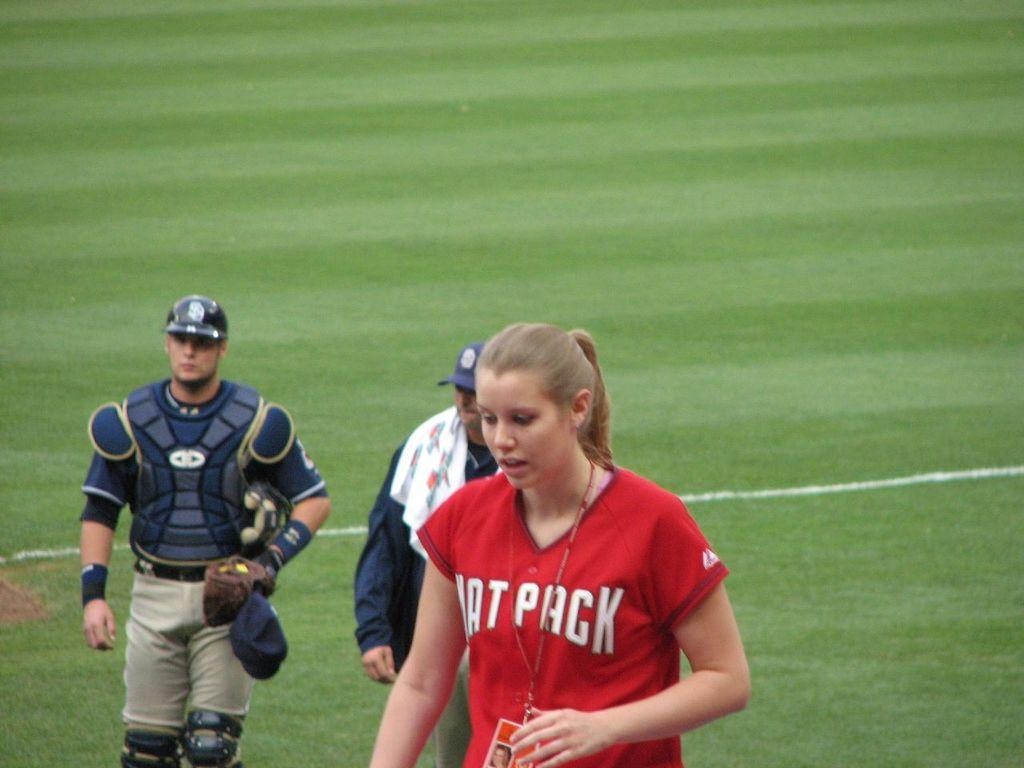<image>
Give a short and clear explanation of the subsequent image. Woman wearing a red jersey that says PACK on it is walking on the field. 